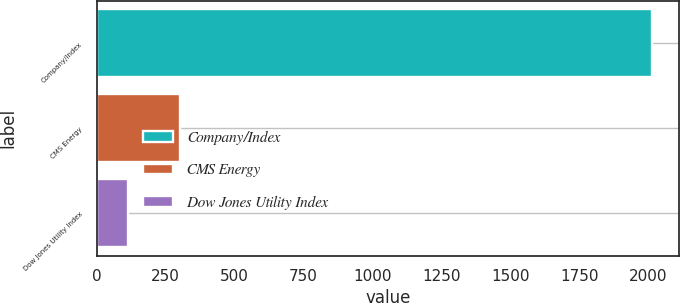Convert chart to OTSL. <chart><loc_0><loc_0><loc_500><loc_500><bar_chart><fcel>Company/Index<fcel>CMS Energy<fcel>Dow Jones Utility Index<nl><fcel>2013<fcel>303<fcel>113<nl></chart> 